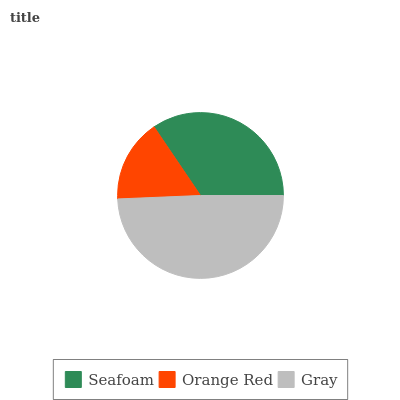Is Orange Red the minimum?
Answer yes or no. Yes. Is Gray the maximum?
Answer yes or no. Yes. Is Gray the minimum?
Answer yes or no. No. Is Orange Red the maximum?
Answer yes or no. No. Is Gray greater than Orange Red?
Answer yes or no. Yes. Is Orange Red less than Gray?
Answer yes or no. Yes. Is Orange Red greater than Gray?
Answer yes or no. No. Is Gray less than Orange Red?
Answer yes or no. No. Is Seafoam the high median?
Answer yes or no. Yes. Is Seafoam the low median?
Answer yes or no. Yes. Is Orange Red the high median?
Answer yes or no. No. Is Gray the low median?
Answer yes or no. No. 